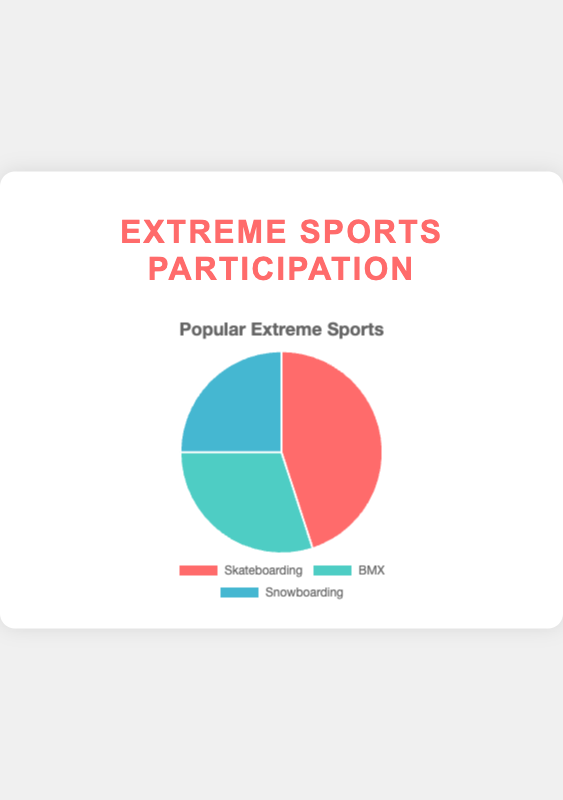Which sport has the highest participation percentage? By looking at the pie chart, it's evident that the segment for Skateboarding covers the most area, indicating that the participation percentage for Skateboarding is the largest of the three sports.
Answer: Skateboarding What is the combined participation percentage for BMX and Snowboarding? The participation percentage for BMX is 30%, and for Snowboarding, it is 25%. Adding these two percentages gives 30% + 25% = 55%.
Answer: 55% How much higher is the participation percentage for Skateboarding compared to Snowboarding? The participation percentage for Skateboarding is 45%, and for Snowboarding, it is 25%. The difference is 45% - 25% = 20%.
Answer: 20% Which sport has the smallest participation percentage? Observing the pie chart, the smallest segment corresponds to Snowboarding. Thus, Snowboarding has the smallest participation percentage.
Answer: Snowboarding Compare the participation percentages of BMX and Snowboarding. Which one is larger and by how much? BMX has a participation percentage of 30%, while Snowboarding has 25%. The difference between the two is 30% - 25% = 5%. Hence, BMX has a larger percentage by 5%.
Answer: BMX by 5% What is the average participation percentage of all three sports? The participation percentages for Skateboarding, BMX, and Snowboarding are 45%, 30%, and 25%, respectively. Adding these and dividing by 3: (45% + 30% + 25%) / 3 = 100% / 3 ≈ 33.33%.
Answer: 33.33% If another sport was added with a participation percentage equal to the average of the current sports, what would the new participation percentage be for the new sport? The average participation percentage is 33.33%. Therefore, if another sport was added with this percentage, it would have a participation percentage of 33.33%.
Answer: 33.33% How does the visual length of the Skateboarding segment compare to the BMX segment? The segment for Skateboarding covers a larger arc in the pie chart compared to the BMX segment, indicating a higher participation percentage visually.
Answer: Larger What is the difference between the largest and smallest participation percentages? The largest participation percentage is for Skateboarding at 45%, and the smallest is for Snowboarding at 25%. The difference is 45% - 25% = 20%.
Answer: 20% What percentage of the total participation is covered by sports other than Skateboarding? The total participation percentage for BMX and Snowboarding together is 30% + 25% = 55%.
Answer: 55% 